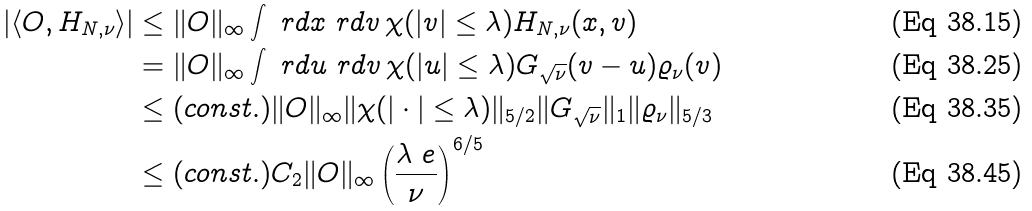Convert formula to latex. <formula><loc_0><loc_0><loc_500><loc_500>| \langle O , H _ { N , \nu } \rangle | & \leq \| O \| _ { \infty } \int \ r d x \ r d v \, \chi ( | v | \leq \lambda ) H _ { N , \nu } ( x , v ) \\ & = \| O \| _ { \infty } \int \ r d u \ r d v \, \chi ( | u | \leq \lambda ) G _ { \sqrt { \nu } } ( v - u ) \varrho _ { \nu } ( v ) \\ & \leq ( c o n s t . ) \| O \| _ { \infty } \| \chi ( | \cdot | \leq \lambda ) \| _ { 5 / 2 } \| G _ { \sqrt { \nu } } \| _ { 1 } \| \varrho _ { \nu } \| _ { 5 / 3 } \\ & \leq ( c o n s t . ) C _ { 2 } \| O \| _ { \infty } \left ( \frac { \lambda \ e } { \nu } \right ) ^ { 6 / 5 }</formula> 